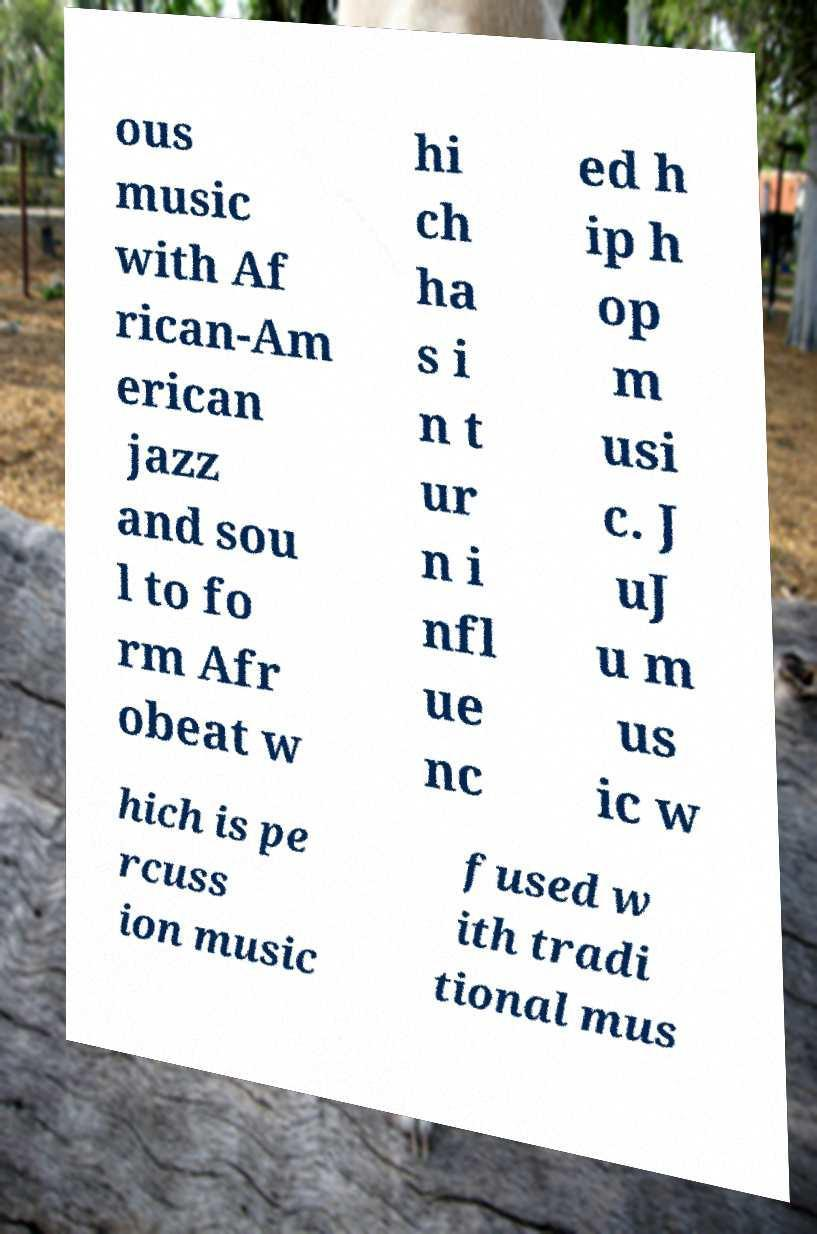Can you accurately transcribe the text from the provided image for me? ous music with Af rican-Am erican jazz and sou l to fo rm Afr obeat w hi ch ha s i n t ur n i nfl ue nc ed h ip h op m usi c. J uJ u m us ic w hich is pe rcuss ion music fused w ith tradi tional mus 